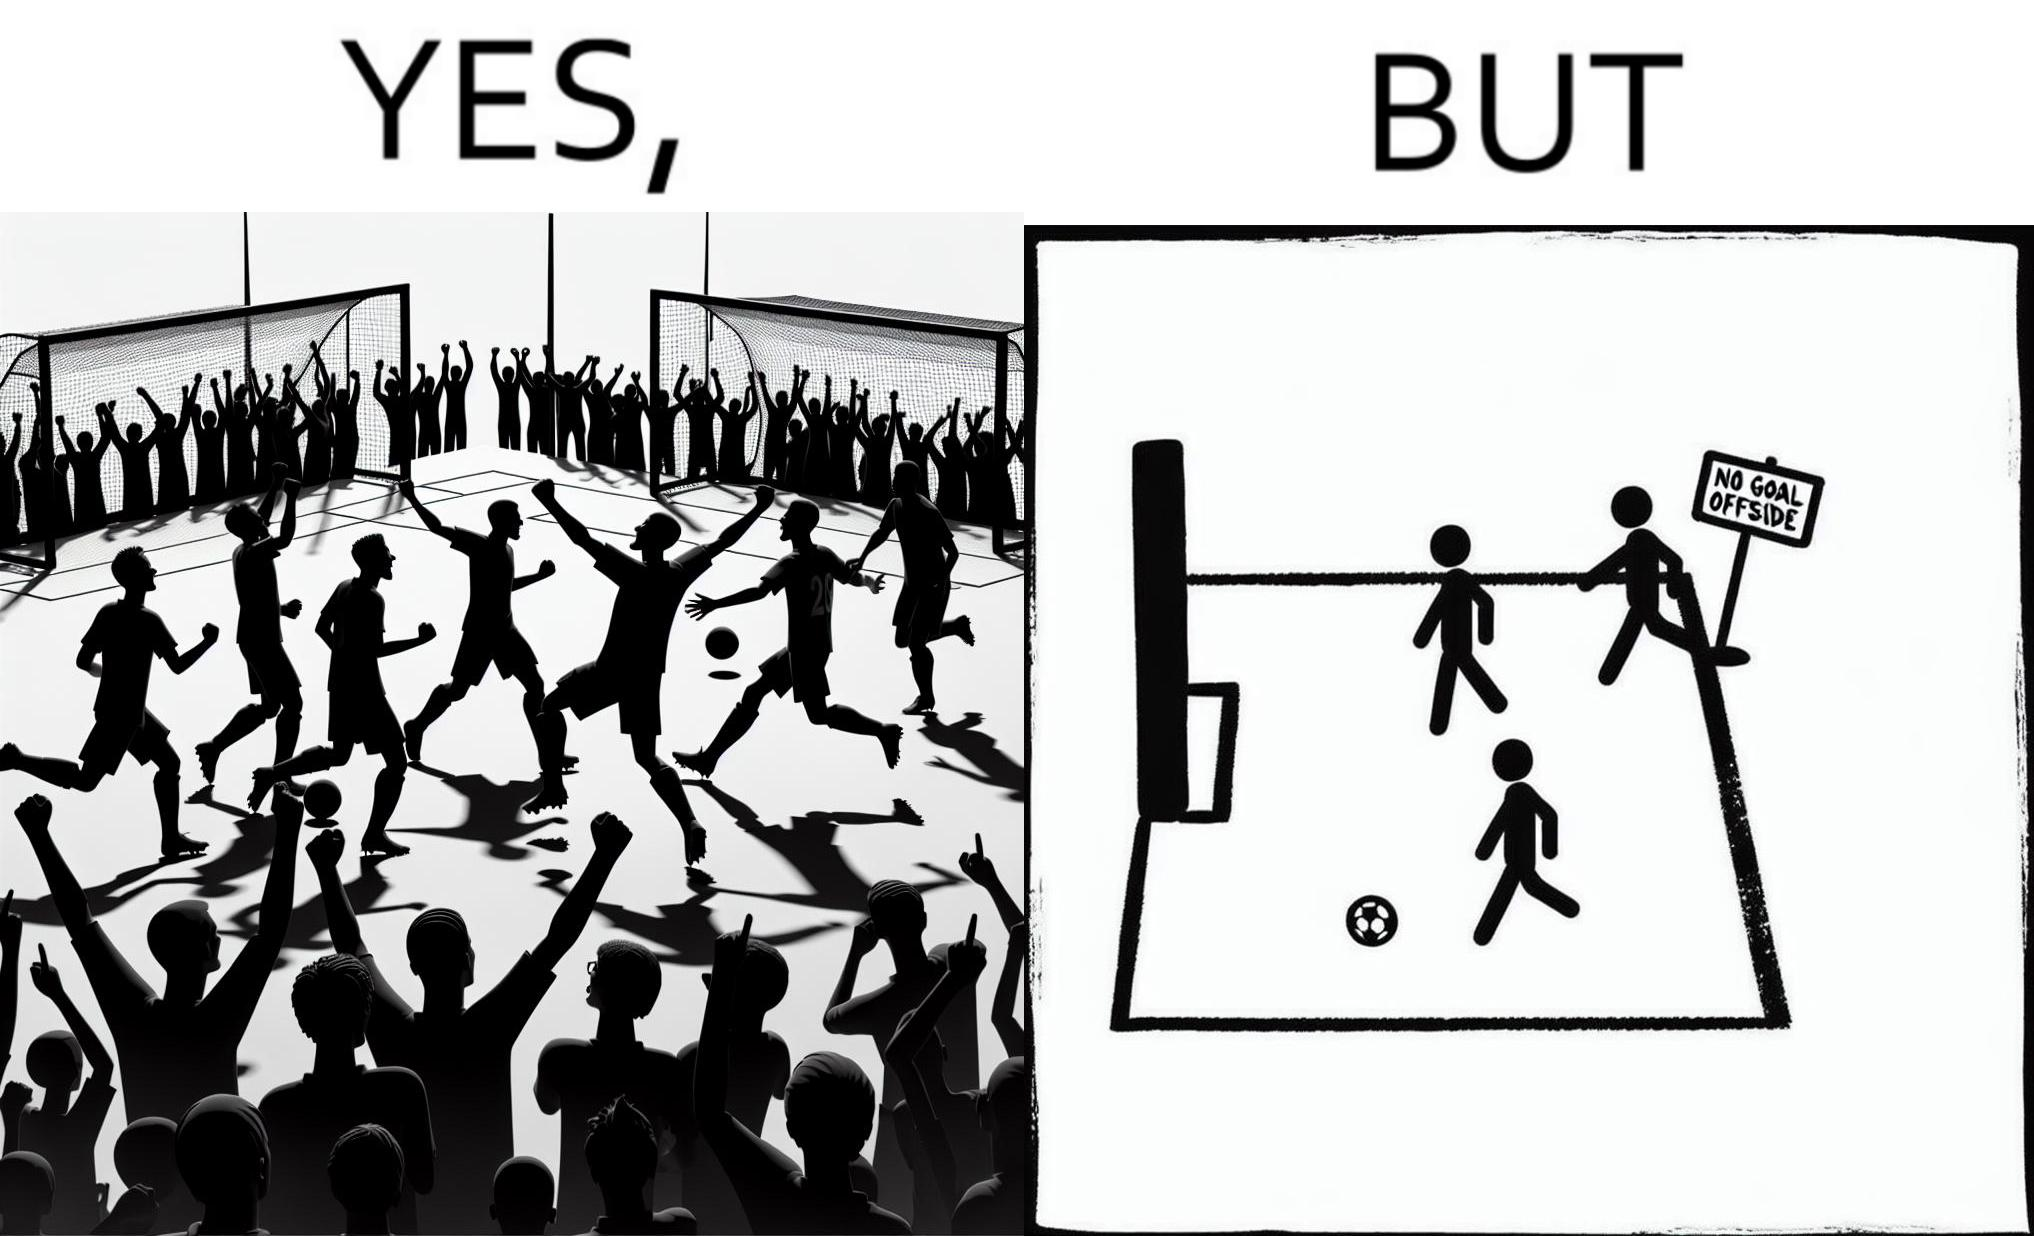What makes this image funny or satirical? The image is ironical, as the team is celebrating as they think that they have scored a goal, but the sign on the screen says that it is an offside, and not a goal. This is a very common scenario in football matches. 